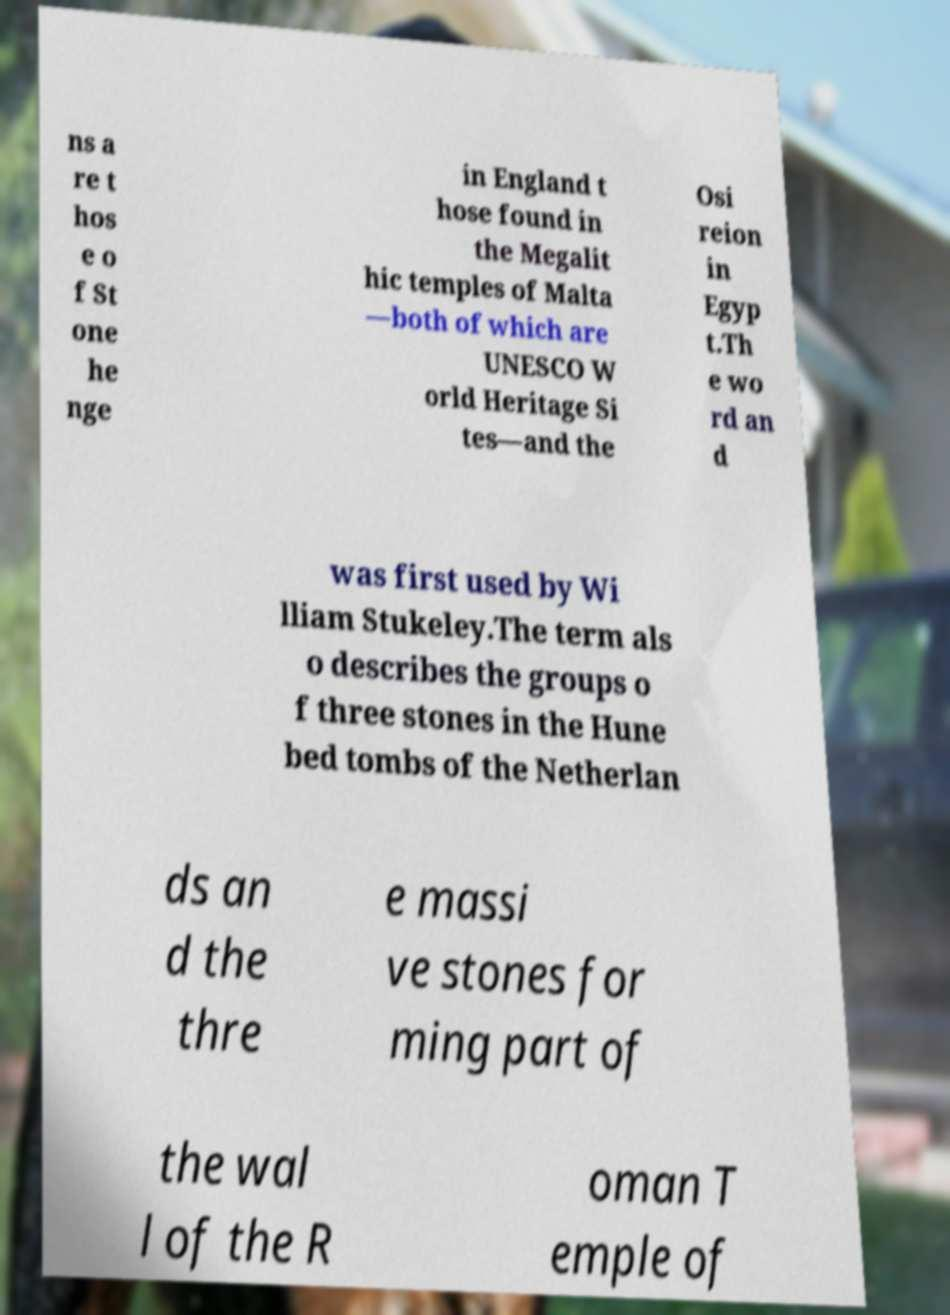There's text embedded in this image that I need extracted. Can you transcribe it verbatim? ns a re t hos e o f St one he nge in England t hose found in the Megalit hic temples of Malta —both of which are UNESCO W orld Heritage Si tes—and the Osi reion in Egyp t.Th e wo rd an d was first used by Wi lliam Stukeley.The term als o describes the groups o f three stones in the Hune bed tombs of the Netherlan ds an d the thre e massi ve stones for ming part of the wal l of the R oman T emple of 